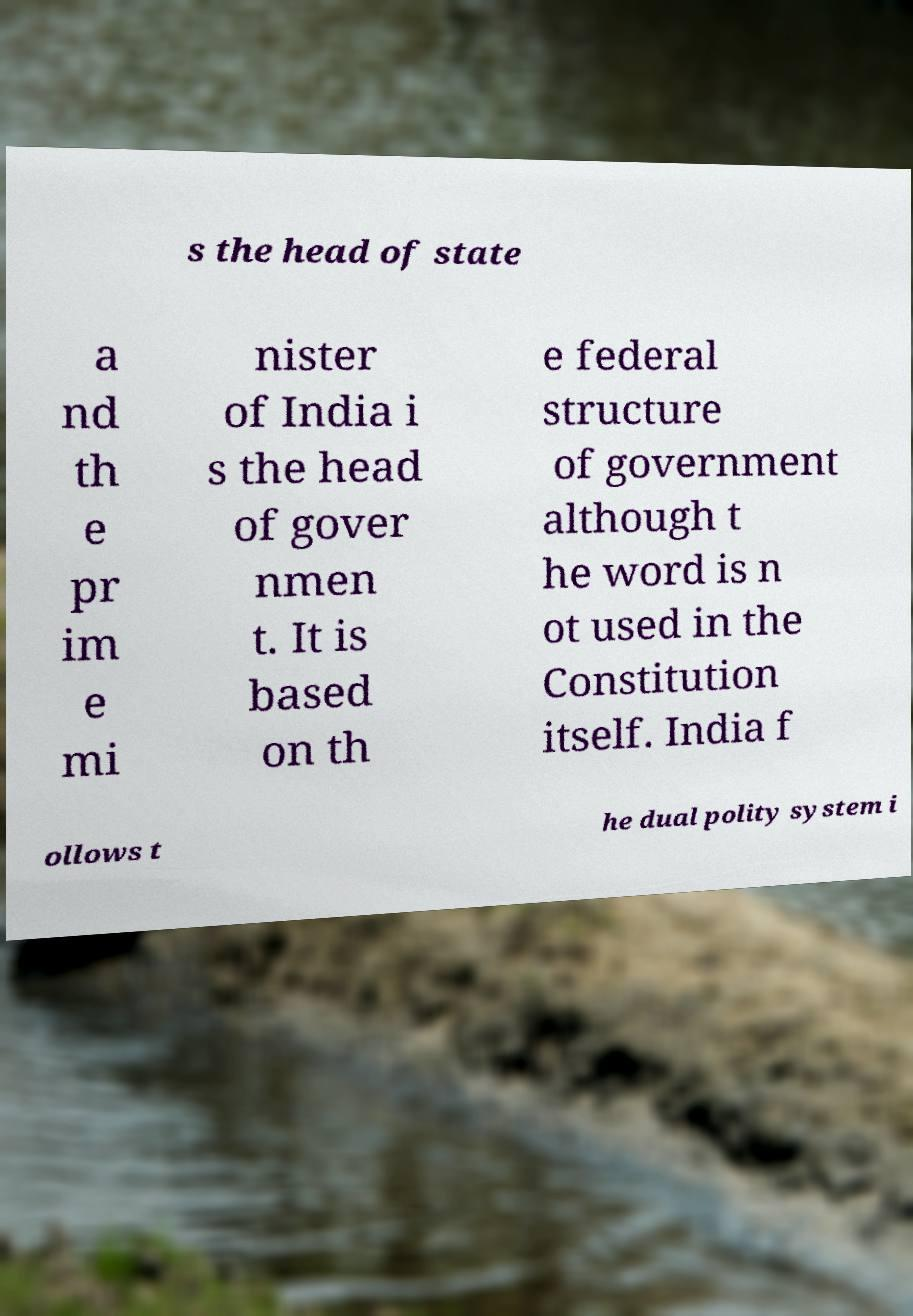Please read and relay the text visible in this image. What does it say? s the head of state a nd th e pr im e mi nister of India i s the head of gover nmen t. It is based on th e federal structure of government although t he word is n ot used in the Constitution itself. India f ollows t he dual polity system i 